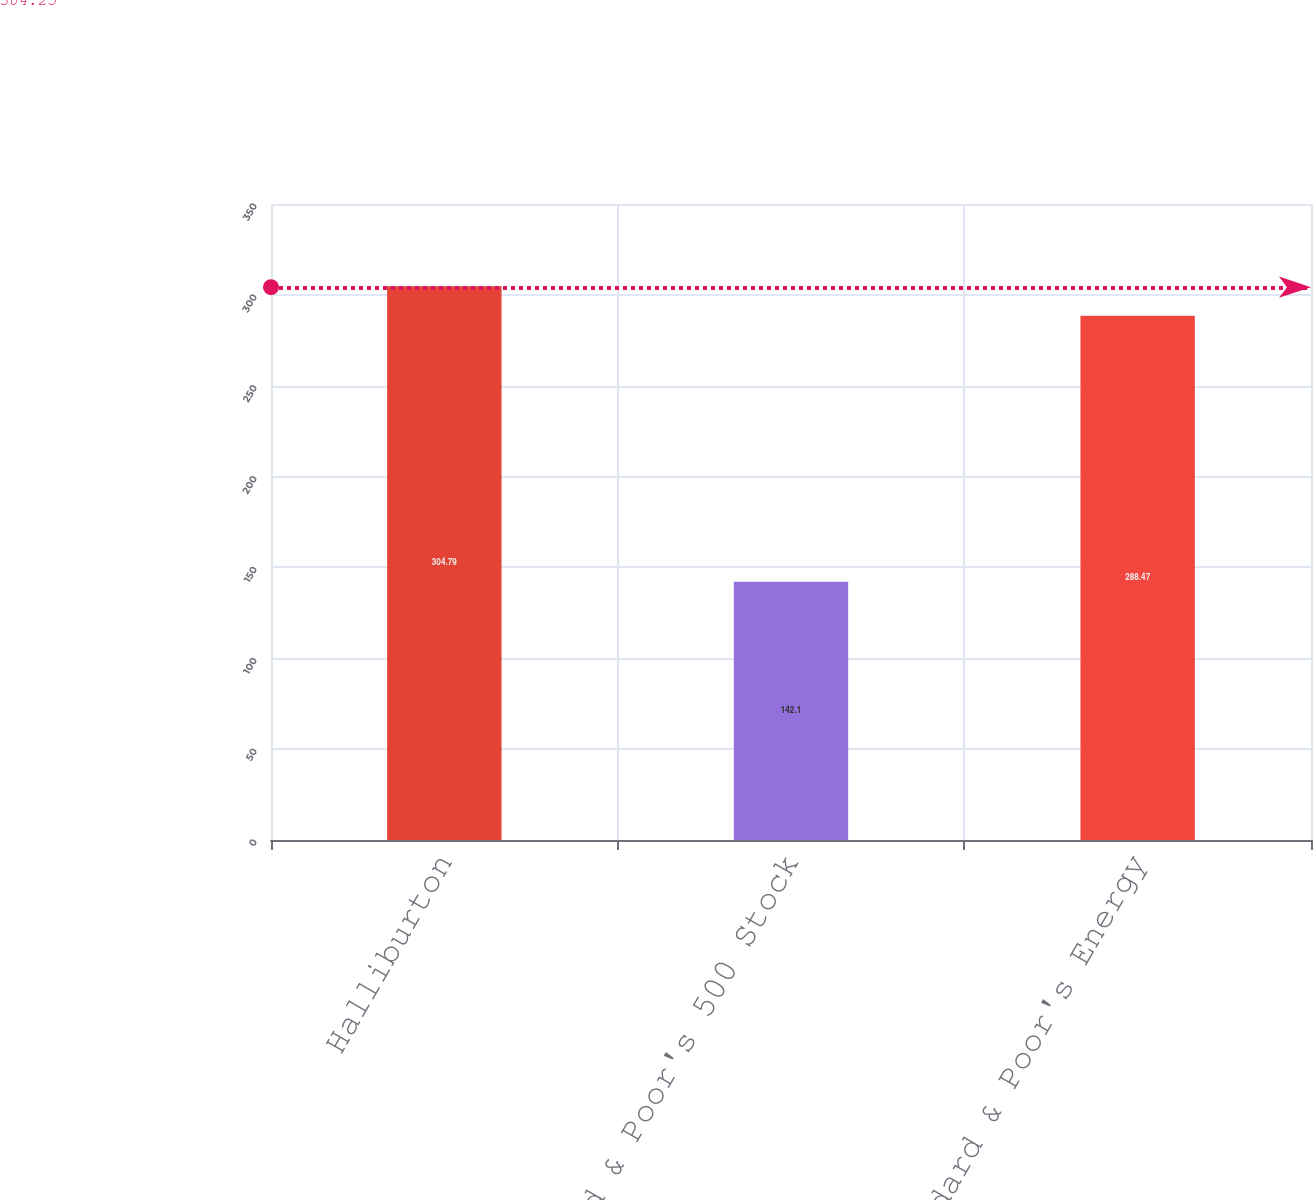Convert chart to OTSL. <chart><loc_0><loc_0><loc_500><loc_500><bar_chart><fcel>Halliburton<fcel>Standard & Poor's 500 Stock<fcel>Standard & Poor's Energy<nl><fcel>304.79<fcel>142.1<fcel>288.47<nl></chart> 